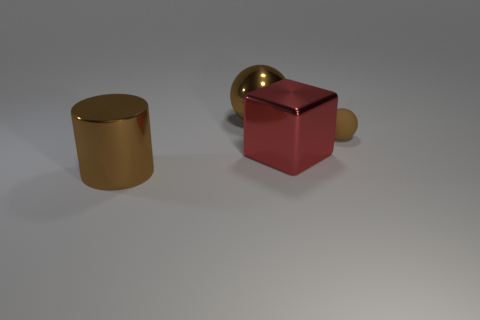Is the color of the big metal object that is behind the cube the same as the tiny sphere?
Your answer should be compact. Yes. There is a red object; what number of big metal balls are on the left side of it?
Provide a succinct answer. 1. Are the red cube and the brown ball that is to the right of the big brown sphere made of the same material?
Keep it short and to the point. No. The brown ball that is made of the same material as the cube is what size?
Make the answer very short. Large. Are there more large cylinders right of the brown matte object than red metal things behind the big cube?
Your answer should be very brief. No. Are there any metallic objects that have the same shape as the brown rubber object?
Offer a very short reply. Yes. Do the brown metal object on the right side of the cylinder and the big brown cylinder have the same size?
Keep it short and to the point. Yes. Are any red things visible?
Make the answer very short. Yes. What number of things are either large brown shiny objects that are in front of the large red block or red shiny things?
Provide a succinct answer. 2. Do the large ball and the large metallic object that is in front of the large block have the same color?
Your answer should be compact. Yes. 